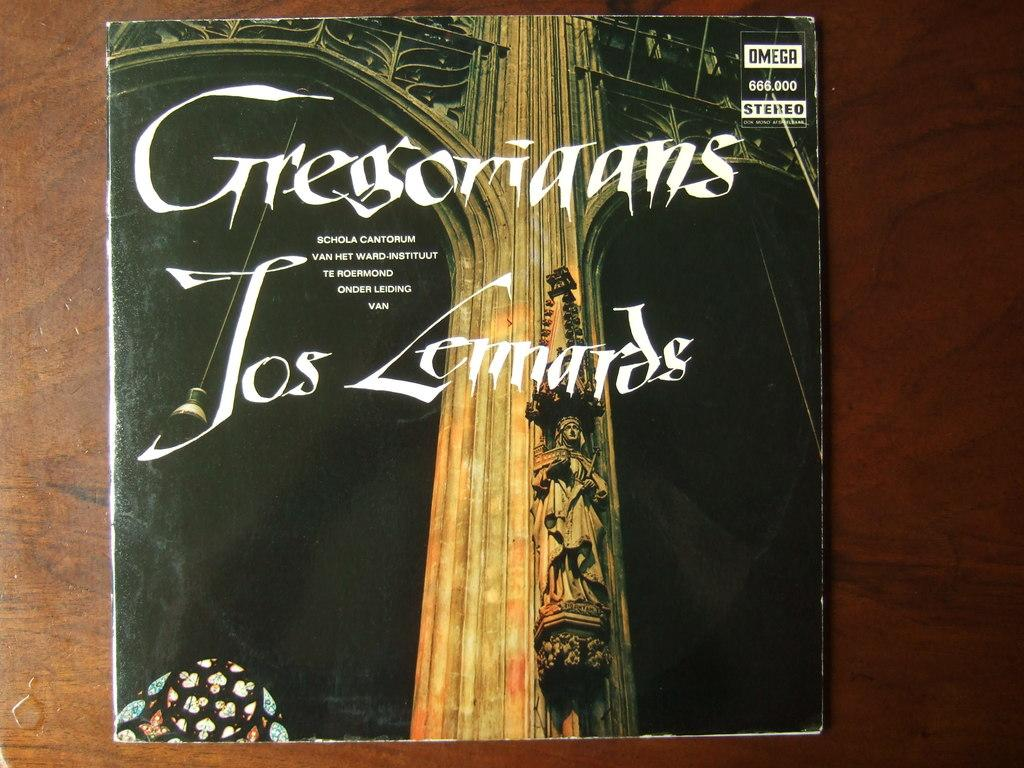<image>
Offer a succinct explanation of the picture presented. A CD of Gregoriaans Jos Lennardes laying on a brown table. 